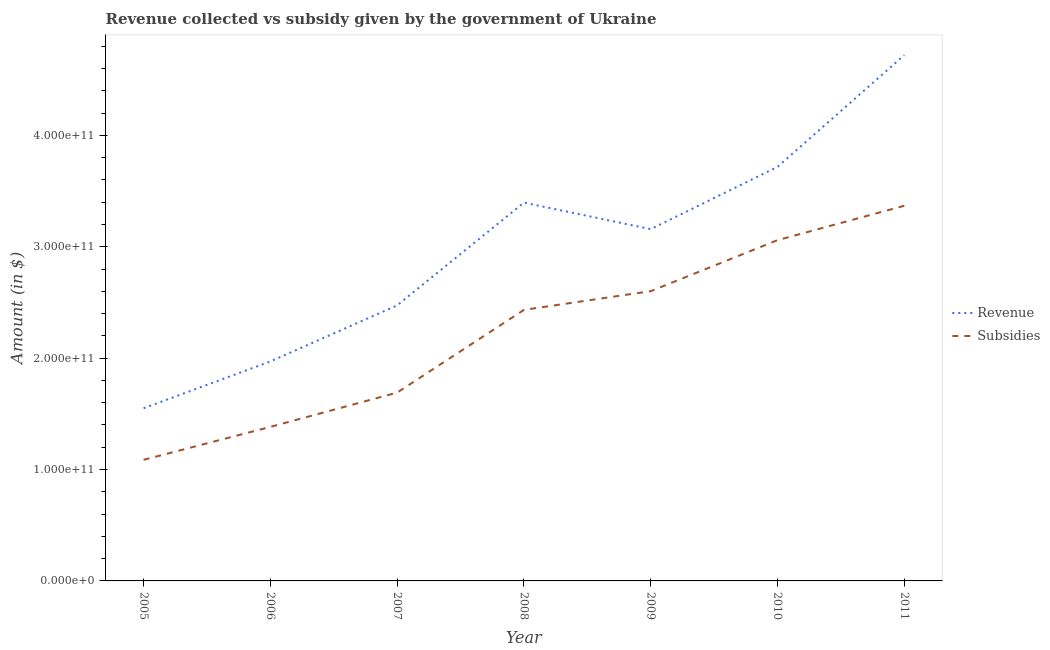Does the line corresponding to amount of revenue collected intersect with the line corresponding to amount of subsidies given?
Provide a succinct answer. No. Is the number of lines equal to the number of legend labels?
Keep it short and to the point. Yes. What is the amount of revenue collected in 2006?
Provide a short and direct response. 1.97e+11. Across all years, what is the maximum amount of revenue collected?
Your answer should be very brief. 4.72e+11. Across all years, what is the minimum amount of revenue collected?
Ensure brevity in your answer.  1.55e+11. In which year was the amount of subsidies given minimum?
Your answer should be very brief. 2005. What is the total amount of subsidies given in the graph?
Your answer should be compact. 1.56e+12. What is the difference between the amount of subsidies given in 2007 and that in 2009?
Your answer should be compact. -9.10e+1. What is the difference between the amount of subsidies given in 2009 and the amount of revenue collected in 2007?
Your response must be concise. 1.28e+1. What is the average amount of subsidies given per year?
Keep it short and to the point. 2.23e+11. In the year 2005, what is the difference between the amount of subsidies given and amount of revenue collected?
Provide a succinct answer. -4.63e+1. What is the ratio of the amount of subsidies given in 2008 to that in 2011?
Your answer should be very brief. 0.72. Is the amount of revenue collected in 2007 less than that in 2010?
Provide a short and direct response. Yes. Is the difference between the amount of revenue collected in 2009 and 2010 greater than the difference between the amount of subsidies given in 2009 and 2010?
Offer a terse response. No. What is the difference between the highest and the second highest amount of revenue collected?
Offer a terse response. 1.00e+11. What is the difference between the highest and the lowest amount of revenue collected?
Provide a short and direct response. 3.17e+11. Is the sum of the amount of revenue collected in 2006 and 2008 greater than the maximum amount of subsidies given across all years?
Offer a very short reply. Yes. Is the amount of revenue collected strictly greater than the amount of subsidies given over the years?
Your answer should be very brief. Yes. How many years are there in the graph?
Offer a very short reply. 7. What is the difference between two consecutive major ticks on the Y-axis?
Offer a terse response. 1.00e+11. Does the graph contain any zero values?
Provide a short and direct response. No. How many legend labels are there?
Offer a very short reply. 2. How are the legend labels stacked?
Provide a short and direct response. Vertical. What is the title of the graph?
Your response must be concise. Revenue collected vs subsidy given by the government of Ukraine. What is the label or title of the X-axis?
Make the answer very short. Year. What is the label or title of the Y-axis?
Your response must be concise. Amount (in $). What is the Amount (in $) of Revenue in 2005?
Offer a terse response. 1.55e+11. What is the Amount (in $) of Subsidies in 2005?
Your answer should be very brief. 1.09e+11. What is the Amount (in $) of Revenue in 2006?
Provide a succinct answer. 1.97e+11. What is the Amount (in $) of Subsidies in 2006?
Provide a succinct answer. 1.38e+11. What is the Amount (in $) of Revenue in 2007?
Your response must be concise. 2.47e+11. What is the Amount (in $) in Subsidies in 2007?
Make the answer very short. 1.69e+11. What is the Amount (in $) in Revenue in 2008?
Make the answer very short. 3.40e+11. What is the Amount (in $) of Subsidies in 2008?
Offer a very short reply. 2.43e+11. What is the Amount (in $) of Revenue in 2009?
Make the answer very short. 3.16e+11. What is the Amount (in $) of Subsidies in 2009?
Offer a very short reply. 2.60e+11. What is the Amount (in $) in Revenue in 2010?
Your response must be concise. 3.72e+11. What is the Amount (in $) of Subsidies in 2010?
Offer a terse response. 3.06e+11. What is the Amount (in $) of Revenue in 2011?
Your answer should be very brief. 4.72e+11. What is the Amount (in $) of Subsidies in 2011?
Your answer should be compact. 3.37e+11. Across all years, what is the maximum Amount (in $) of Revenue?
Your answer should be compact. 4.72e+11. Across all years, what is the maximum Amount (in $) in Subsidies?
Keep it short and to the point. 3.37e+11. Across all years, what is the minimum Amount (in $) in Revenue?
Your response must be concise. 1.55e+11. Across all years, what is the minimum Amount (in $) of Subsidies?
Provide a succinct answer. 1.09e+11. What is the total Amount (in $) of Revenue in the graph?
Keep it short and to the point. 2.10e+12. What is the total Amount (in $) in Subsidies in the graph?
Ensure brevity in your answer.  1.56e+12. What is the difference between the Amount (in $) in Revenue in 2005 and that in 2006?
Give a very brief answer. -4.20e+1. What is the difference between the Amount (in $) in Subsidies in 2005 and that in 2006?
Provide a succinct answer. -2.96e+1. What is the difference between the Amount (in $) in Revenue in 2005 and that in 2007?
Your answer should be very brief. -9.24e+1. What is the difference between the Amount (in $) in Subsidies in 2005 and that in 2007?
Provide a succinct answer. -6.04e+1. What is the difference between the Amount (in $) in Revenue in 2005 and that in 2008?
Give a very brief answer. -1.85e+11. What is the difference between the Amount (in $) of Subsidies in 2005 and that in 2008?
Offer a terse response. -1.35e+11. What is the difference between the Amount (in $) in Revenue in 2005 and that in 2009?
Offer a terse response. -1.61e+11. What is the difference between the Amount (in $) in Subsidies in 2005 and that in 2009?
Offer a very short reply. -1.51e+11. What is the difference between the Amount (in $) of Revenue in 2005 and that in 2010?
Keep it short and to the point. -2.17e+11. What is the difference between the Amount (in $) in Subsidies in 2005 and that in 2010?
Offer a very short reply. -1.97e+11. What is the difference between the Amount (in $) in Revenue in 2005 and that in 2011?
Ensure brevity in your answer.  -3.17e+11. What is the difference between the Amount (in $) in Subsidies in 2005 and that in 2011?
Give a very brief answer. -2.28e+11. What is the difference between the Amount (in $) of Revenue in 2006 and that in 2007?
Give a very brief answer. -5.03e+1. What is the difference between the Amount (in $) in Subsidies in 2006 and that in 2007?
Your answer should be compact. -3.08e+1. What is the difference between the Amount (in $) of Revenue in 2006 and that in 2008?
Offer a very short reply. -1.43e+11. What is the difference between the Amount (in $) of Subsidies in 2006 and that in 2008?
Your response must be concise. -1.05e+11. What is the difference between the Amount (in $) in Revenue in 2006 and that in 2009?
Give a very brief answer. -1.19e+11. What is the difference between the Amount (in $) in Subsidies in 2006 and that in 2009?
Offer a terse response. -1.22e+11. What is the difference between the Amount (in $) of Revenue in 2006 and that in 2010?
Your response must be concise. -1.75e+11. What is the difference between the Amount (in $) in Subsidies in 2006 and that in 2010?
Make the answer very short. -1.68e+11. What is the difference between the Amount (in $) of Revenue in 2006 and that in 2011?
Provide a succinct answer. -2.75e+11. What is the difference between the Amount (in $) of Subsidies in 2006 and that in 2011?
Offer a terse response. -1.98e+11. What is the difference between the Amount (in $) in Revenue in 2007 and that in 2008?
Keep it short and to the point. -9.23e+1. What is the difference between the Amount (in $) in Subsidies in 2007 and that in 2008?
Offer a terse response. -7.42e+1. What is the difference between the Amount (in $) of Revenue in 2007 and that in 2009?
Keep it short and to the point. -6.84e+1. What is the difference between the Amount (in $) of Subsidies in 2007 and that in 2009?
Offer a terse response. -9.10e+1. What is the difference between the Amount (in $) of Revenue in 2007 and that in 2010?
Your response must be concise. -1.24e+11. What is the difference between the Amount (in $) of Subsidies in 2007 and that in 2010?
Give a very brief answer. -1.37e+11. What is the difference between the Amount (in $) of Revenue in 2007 and that in 2011?
Provide a succinct answer. -2.25e+11. What is the difference between the Amount (in $) of Subsidies in 2007 and that in 2011?
Your response must be concise. -1.68e+11. What is the difference between the Amount (in $) in Revenue in 2008 and that in 2009?
Offer a very short reply. 2.38e+1. What is the difference between the Amount (in $) of Subsidies in 2008 and that in 2009?
Provide a succinct answer. -1.68e+1. What is the difference between the Amount (in $) of Revenue in 2008 and that in 2010?
Ensure brevity in your answer.  -3.21e+1. What is the difference between the Amount (in $) in Subsidies in 2008 and that in 2010?
Your response must be concise. -6.26e+1. What is the difference between the Amount (in $) of Revenue in 2008 and that in 2011?
Offer a very short reply. -1.32e+11. What is the difference between the Amount (in $) in Subsidies in 2008 and that in 2011?
Your response must be concise. -9.35e+1. What is the difference between the Amount (in $) in Revenue in 2009 and that in 2010?
Your answer should be very brief. -5.59e+1. What is the difference between the Amount (in $) in Subsidies in 2009 and that in 2010?
Provide a short and direct response. -4.58e+1. What is the difference between the Amount (in $) of Revenue in 2009 and that in 2011?
Your answer should be very brief. -1.56e+11. What is the difference between the Amount (in $) of Subsidies in 2009 and that in 2011?
Give a very brief answer. -7.67e+1. What is the difference between the Amount (in $) in Revenue in 2010 and that in 2011?
Make the answer very short. -1.00e+11. What is the difference between the Amount (in $) of Subsidies in 2010 and that in 2011?
Give a very brief answer. -3.09e+1. What is the difference between the Amount (in $) in Revenue in 2005 and the Amount (in $) in Subsidies in 2006?
Make the answer very short. 1.67e+1. What is the difference between the Amount (in $) of Revenue in 2005 and the Amount (in $) of Subsidies in 2007?
Keep it short and to the point. -1.41e+1. What is the difference between the Amount (in $) in Revenue in 2005 and the Amount (in $) in Subsidies in 2008?
Provide a short and direct response. -8.83e+1. What is the difference between the Amount (in $) in Revenue in 2005 and the Amount (in $) in Subsidies in 2009?
Provide a short and direct response. -1.05e+11. What is the difference between the Amount (in $) of Revenue in 2005 and the Amount (in $) of Subsidies in 2010?
Provide a succinct answer. -1.51e+11. What is the difference between the Amount (in $) in Revenue in 2005 and the Amount (in $) in Subsidies in 2011?
Offer a very short reply. -1.82e+11. What is the difference between the Amount (in $) in Revenue in 2006 and the Amount (in $) in Subsidies in 2007?
Give a very brief answer. 2.79e+1. What is the difference between the Amount (in $) in Revenue in 2006 and the Amount (in $) in Subsidies in 2008?
Make the answer very short. -4.63e+1. What is the difference between the Amount (in $) of Revenue in 2006 and the Amount (in $) of Subsidies in 2009?
Your answer should be compact. -6.31e+1. What is the difference between the Amount (in $) in Revenue in 2006 and the Amount (in $) in Subsidies in 2010?
Provide a short and direct response. -1.09e+11. What is the difference between the Amount (in $) in Revenue in 2006 and the Amount (in $) in Subsidies in 2011?
Ensure brevity in your answer.  -1.40e+11. What is the difference between the Amount (in $) of Revenue in 2007 and the Amount (in $) of Subsidies in 2008?
Your answer should be compact. 4.04e+09. What is the difference between the Amount (in $) in Revenue in 2007 and the Amount (in $) in Subsidies in 2009?
Provide a succinct answer. -1.28e+1. What is the difference between the Amount (in $) of Revenue in 2007 and the Amount (in $) of Subsidies in 2010?
Your answer should be very brief. -5.85e+1. What is the difference between the Amount (in $) in Revenue in 2007 and the Amount (in $) in Subsidies in 2011?
Keep it short and to the point. -8.94e+1. What is the difference between the Amount (in $) of Revenue in 2008 and the Amount (in $) of Subsidies in 2009?
Provide a short and direct response. 7.95e+1. What is the difference between the Amount (in $) of Revenue in 2008 and the Amount (in $) of Subsidies in 2010?
Give a very brief answer. 3.37e+1. What is the difference between the Amount (in $) in Revenue in 2008 and the Amount (in $) in Subsidies in 2011?
Your answer should be compact. 2.83e+09. What is the difference between the Amount (in $) of Revenue in 2009 and the Amount (in $) of Subsidies in 2010?
Your response must be concise. 9.89e+09. What is the difference between the Amount (in $) of Revenue in 2009 and the Amount (in $) of Subsidies in 2011?
Provide a short and direct response. -2.10e+1. What is the difference between the Amount (in $) of Revenue in 2010 and the Amount (in $) of Subsidies in 2011?
Your answer should be very brief. 3.49e+1. What is the average Amount (in $) in Revenue per year?
Your answer should be compact. 3.00e+11. What is the average Amount (in $) in Subsidies per year?
Offer a terse response. 2.23e+11. In the year 2005, what is the difference between the Amount (in $) of Revenue and Amount (in $) of Subsidies?
Provide a short and direct response. 4.63e+1. In the year 2006, what is the difference between the Amount (in $) of Revenue and Amount (in $) of Subsidies?
Your answer should be compact. 5.87e+1. In the year 2007, what is the difference between the Amount (in $) of Revenue and Amount (in $) of Subsidies?
Offer a terse response. 7.83e+1. In the year 2008, what is the difference between the Amount (in $) of Revenue and Amount (in $) of Subsidies?
Offer a very short reply. 9.63e+1. In the year 2009, what is the difference between the Amount (in $) of Revenue and Amount (in $) of Subsidies?
Give a very brief answer. 5.57e+1. In the year 2010, what is the difference between the Amount (in $) of Revenue and Amount (in $) of Subsidies?
Provide a succinct answer. 6.58e+1. In the year 2011, what is the difference between the Amount (in $) in Revenue and Amount (in $) in Subsidies?
Provide a short and direct response. 1.35e+11. What is the ratio of the Amount (in $) in Revenue in 2005 to that in 2006?
Ensure brevity in your answer.  0.79. What is the ratio of the Amount (in $) in Subsidies in 2005 to that in 2006?
Offer a very short reply. 0.79. What is the ratio of the Amount (in $) in Revenue in 2005 to that in 2007?
Keep it short and to the point. 0.63. What is the ratio of the Amount (in $) of Subsidies in 2005 to that in 2007?
Your response must be concise. 0.64. What is the ratio of the Amount (in $) of Revenue in 2005 to that in 2008?
Provide a succinct answer. 0.46. What is the ratio of the Amount (in $) of Subsidies in 2005 to that in 2008?
Give a very brief answer. 0.45. What is the ratio of the Amount (in $) in Revenue in 2005 to that in 2009?
Offer a terse response. 0.49. What is the ratio of the Amount (in $) of Subsidies in 2005 to that in 2009?
Ensure brevity in your answer.  0.42. What is the ratio of the Amount (in $) of Revenue in 2005 to that in 2010?
Offer a very short reply. 0.42. What is the ratio of the Amount (in $) in Subsidies in 2005 to that in 2010?
Offer a very short reply. 0.36. What is the ratio of the Amount (in $) in Revenue in 2005 to that in 2011?
Offer a very short reply. 0.33. What is the ratio of the Amount (in $) in Subsidies in 2005 to that in 2011?
Your response must be concise. 0.32. What is the ratio of the Amount (in $) in Revenue in 2006 to that in 2007?
Keep it short and to the point. 0.8. What is the ratio of the Amount (in $) of Subsidies in 2006 to that in 2007?
Offer a very short reply. 0.82. What is the ratio of the Amount (in $) in Revenue in 2006 to that in 2008?
Your response must be concise. 0.58. What is the ratio of the Amount (in $) in Subsidies in 2006 to that in 2008?
Provide a short and direct response. 0.57. What is the ratio of the Amount (in $) in Revenue in 2006 to that in 2009?
Give a very brief answer. 0.62. What is the ratio of the Amount (in $) in Subsidies in 2006 to that in 2009?
Ensure brevity in your answer.  0.53. What is the ratio of the Amount (in $) in Revenue in 2006 to that in 2010?
Give a very brief answer. 0.53. What is the ratio of the Amount (in $) of Subsidies in 2006 to that in 2010?
Keep it short and to the point. 0.45. What is the ratio of the Amount (in $) in Revenue in 2006 to that in 2011?
Offer a terse response. 0.42. What is the ratio of the Amount (in $) of Subsidies in 2006 to that in 2011?
Your answer should be compact. 0.41. What is the ratio of the Amount (in $) of Revenue in 2007 to that in 2008?
Your answer should be compact. 0.73. What is the ratio of the Amount (in $) of Subsidies in 2007 to that in 2008?
Provide a succinct answer. 0.69. What is the ratio of the Amount (in $) of Revenue in 2007 to that in 2009?
Offer a very short reply. 0.78. What is the ratio of the Amount (in $) of Subsidies in 2007 to that in 2009?
Your answer should be very brief. 0.65. What is the ratio of the Amount (in $) in Revenue in 2007 to that in 2010?
Give a very brief answer. 0.67. What is the ratio of the Amount (in $) in Subsidies in 2007 to that in 2010?
Ensure brevity in your answer.  0.55. What is the ratio of the Amount (in $) in Revenue in 2007 to that in 2011?
Your answer should be very brief. 0.52. What is the ratio of the Amount (in $) of Subsidies in 2007 to that in 2011?
Offer a very short reply. 0.5. What is the ratio of the Amount (in $) in Revenue in 2008 to that in 2009?
Your response must be concise. 1.08. What is the ratio of the Amount (in $) of Subsidies in 2008 to that in 2009?
Give a very brief answer. 0.94. What is the ratio of the Amount (in $) of Revenue in 2008 to that in 2010?
Make the answer very short. 0.91. What is the ratio of the Amount (in $) of Subsidies in 2008 to that in 2010?
Your response must be concise. 0.8. What is the ratio of the Amount (in $) in Revenue in 2008 to that in 2011?
Your response must be concise. 0.72. What is the ratio of the Amount (in $) of Subsidies in 2008 to that in 2011?
Offer a very short reply. 0.72. What is the ratio of the Amount (in $) in Revenue in 2009 to that in 2010?
Make the answer very short. 0.85. What is the ratio of the Amount (in $) of Subsidies in 2009 to that in 2010?
Offer a terse response. 0.85. What is the ratio of the Amount (in $) of Revenue in 2009 to that in 2011?
Give a very brief answer. 0.67. What is the ratio of the Amount (in $) in Subsidies in 2009 to that in 2011?
Provide a short and direct response. 0.77. What is the ratio of the Amount (in $) in Revenue in 2010 to that in 2011?
Your answer should be very brief. 0.79. What is the ratio of the Amount (in $) in Subsidies in 2010 to that in 2011?
Make the answer very short. 0.91. What is the difference between the highest and the second highest Amount (in $) of Revenue?
Make the answer very short. 1.00e+11. What is the difference between the highest and the second highest Amount (in $) of Subsidies?
Provide a short and direct response. 3.09e+1. What is the difference between the highest and the lowest Amount (in $) of Revenue?
Provide a short and direct response. 3.17e+11. What is the difference between the highest and the lowest Amount (in $) of Subsidies?
Keep it short and to the point. 2.28e+11. 